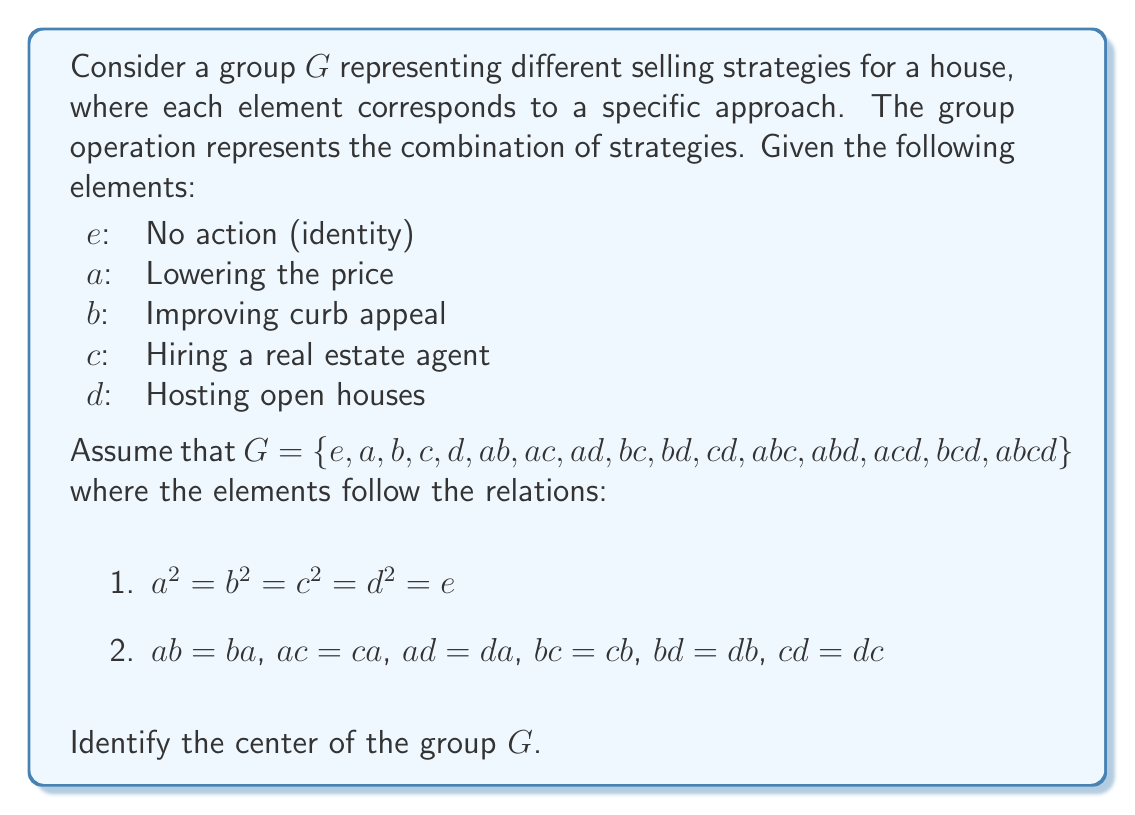What is the answer to this math problem? To find the center of the group $G$, we need to identify all elements that commute with every other element in the group. Let's approach this step-by-step:

1) First, recall that the center of a group $G$ is defined as:
   $$Z(G) = \{z \in G \mid zg = gz \text{ for all } g \in G\}$$

2) We know that the identity element $e$ always commutes with all elements, so $e$ is always in the center.

3) From the given relations, we can see that $a$, $b$, $c$, and $d$ commute with each other. However, this doesn't guarantee that they commute with all composite elements.

4) Let's check if $a$ commutes with all elements:
   - $a$ commutes with $e$, $b$, $c$, $d$ (given)
   - $a(ab) = a^2b = eb = b = (ab)a$
   - $a(ac) = a^2c = ec = c = (ac)a$
   - $a(ad) = a^2d = ed = d = (ad)a$
   - $a(bc) = abc = (bc)a$
   - $a(bd) = abd = (bd)a$
   - $a(cd) = acd = (cd)a$
   - $a(abc) = a^2bc = ebc = bc = (abc)a$
   - $a(abd) = a^2bd = ebd = bd = (abd)a$
   - $a(acd) = a^2cd = ecd = cd = (acd)a$
   - $a(bcd) = abcd = (bcd)a$
   - $a(abcd) = a^2bcd = ebcd = bcd = (abcd)a$

5) We can perform similar checks for $b$, $c$, and $d$, and we'll find that they also commute with all elements of $G$.

6) For composite elements like $ab$, $abc$, etc., we can check that they don't commute with all elements. For example:
   $(ab)c = abc \neq cab = c(ab)$

Therefore, the center of the group $G$ consists of $\{e, a, b, c, d\}$.
Answer: The center of the group $G$ is $Z(G) = \{e, a, b, c, d\}$. 